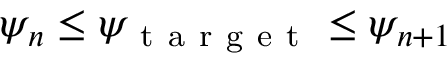Convert formula to latex. <formula><loc_0><loc_0><loc_500><loc_500>\psi _ { n } \leq \psi _ { t a r g e t } \leq \psi _ { n + 1 }</formula> 